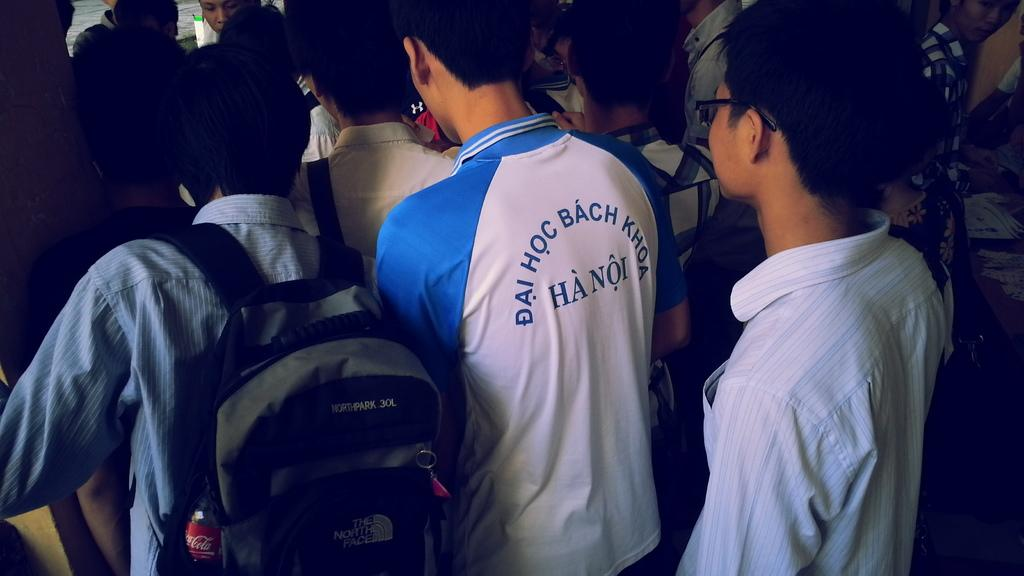<image>
Provide a brief description of the given image. Man wearing a jacket that says "Hanoi" on it. 